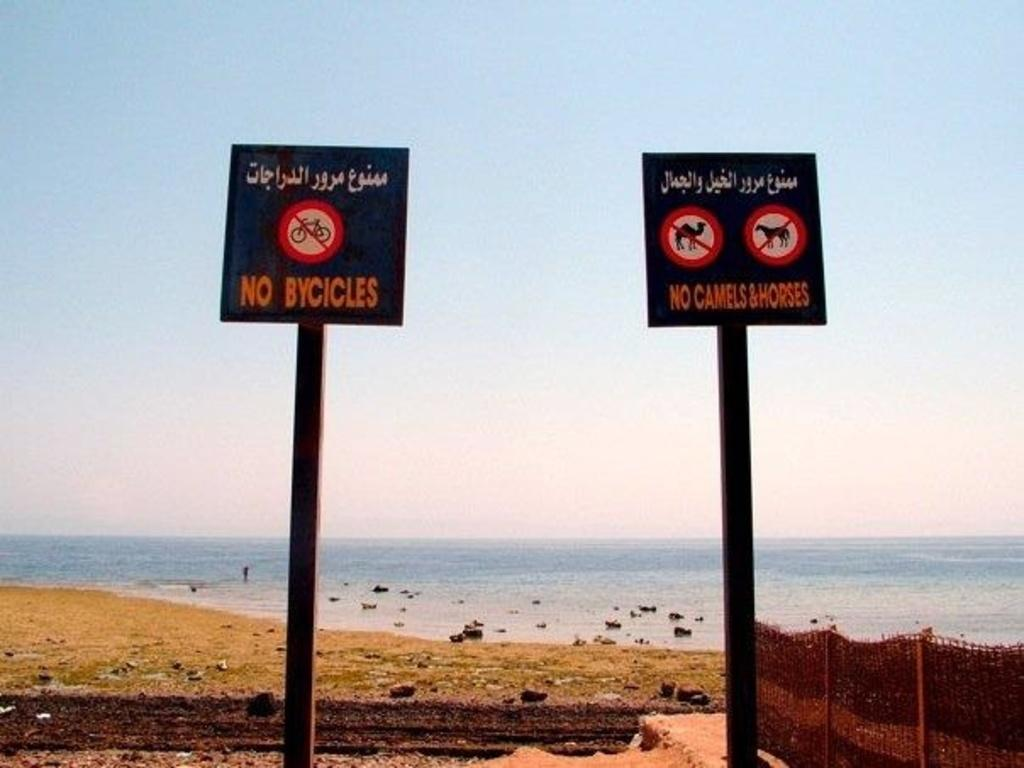Provide a one-sentence caption for the provided image. Near a becah, there are two signs that say no bikes and no camels and horses. 